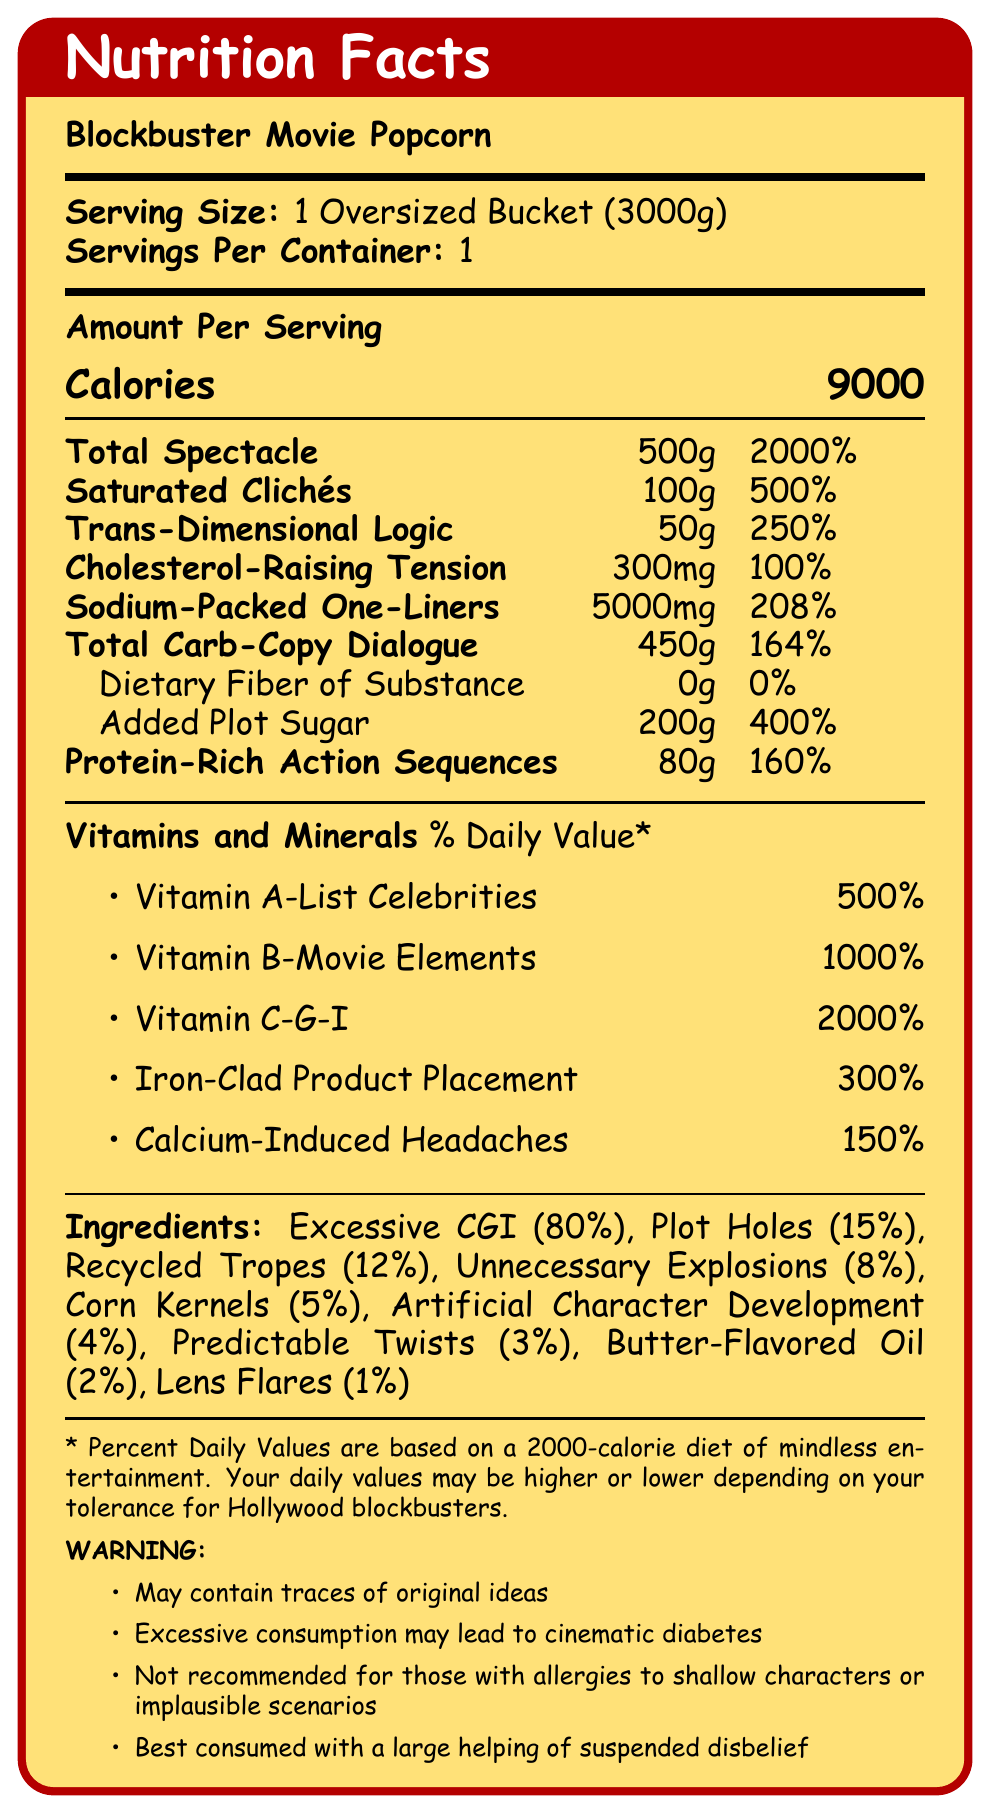what is the serving size? The serving size is clearly stated at the beginning of the Nutrition Facts section as "1 Oversized Bucket (3000g)".
Answer: 1 Oversized Bucket (3000g) how many calories are there per serving? The calories per serving are prominently displayed as 9000 in the Amount Per Serving section.
Answer: 9000 what ingredient makes up the largest portion of Blockbuster Movie Popcorn? The ingredient list shows "Excessive CGI" at 80%, which is the highest percentage among all ingredients.
Answer: Excessive CGI (80%) describe the warning given about excessive consumption. The warning section states that "Excessive consumption may lead to cinematic diabetes".
Answer: Excessive consumption may lead to cinematic diabetes what is the daily value percentage of Sodium-Packed One-Liners? The nutritional content section lists Sodium-Packed One-Liners as having a daily value of 208%.
Answer: 208% which of the following is NOT listed as an ingredient in Blockbuster Movie Popcorn? A. Predictable Twists B. Overacting C. Lens Flares The ingredients include Predictable Twists and Lens Flares, but not Overacting.
Answer: B. Overacting what vitamin and mineral has the highest daily value percentage? A. Vitamin A-List Celebrities B. Vitamin C-G-I C. Iron-Clad Product Placement D. Calcium-Induced Headaches The Vitamin and Mineral section shows Vitamin C-G-I with a 2000% daily value, the highest among listed items.
Answer: B. Vitamin C-G-I how much "Dietary Fiber of Substance" is present? The document states that Dietary Fiber of Substance is 0g.
Answer: 0g is it recommended for those with allergies to shallow characters to consume this product? The warning section specifies that Blockbuster Movie Popcorn is "Not recommended for those with allergies to shallow characters or implausible scenarios".
Answer: No summarize the main idea of the document. This summary encapsulates the playful nature and satirical elements by outlining that the document humorously presents nutritional and ingredient content in the guise of blockbuster movie traits.
Answer: The document is a sardonic Nutrition Facts label for "Blockbuster Movie Popcorn" that humorously emphasizes its components, likening cinematic elements to nutritional values, and provides whimsical warnings about its consumption. how many grams of Trans-Dimensional Logic are present? The nutritional content section lists Trans-Dimensional Logic as 50g.
Answer: 50g what percentage of Recycled Tropes are in the ingredients? The ingredient list specifies that Recycled Tropes make up 12% of the product.
Answer: 12% which vitamin has a higher daily value percentage: Vitamin A-List Celebrities or Vitamin B-Movie Elements? The vitamins and minerals section shows Vitamin B-Movie Elements at 1000% versus Vitamin A-List Celebrities at 500%.
Answer: Vitamin B-Movie Elements are there any original ideas in the product? The warning section humorously states that the product "may contain traces of original ideas," but this cannot be definitively determined from the given information.
Answer: Cannot be determined what is the total amount of protein-rich action sequences? The nutritional content section lists Protein-Rich Action Sequences as 80g.
Answer: 80g what is the daily value percentage of Cholesterol-Raising Tension? In the Amount Per Serving section, Cholesterol-Raising Tension is listed with a daily value of 100%.
Answer: 100% contains what ingredient, making up 15% of the product? The ingredient list shows Plot Holes as 15% of the product.
Answer: Plot Holes 